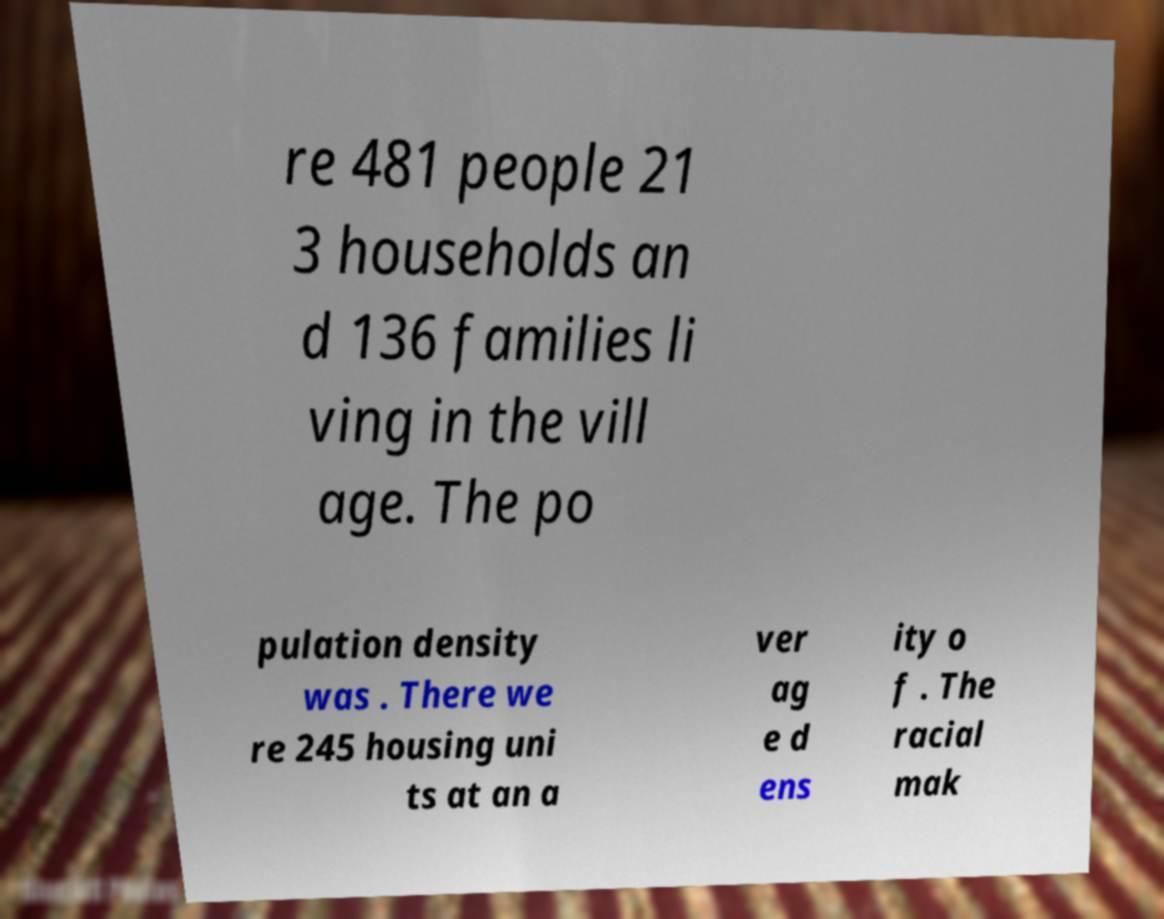Can you accurately transcribe the text from the provided image for me? re 481 people 21 3 households an d 136 families li ving in the vill age. The po pulation density was . There we re 245 housing uni ts at an a ver ag e d ens ity o f . The racial mak 